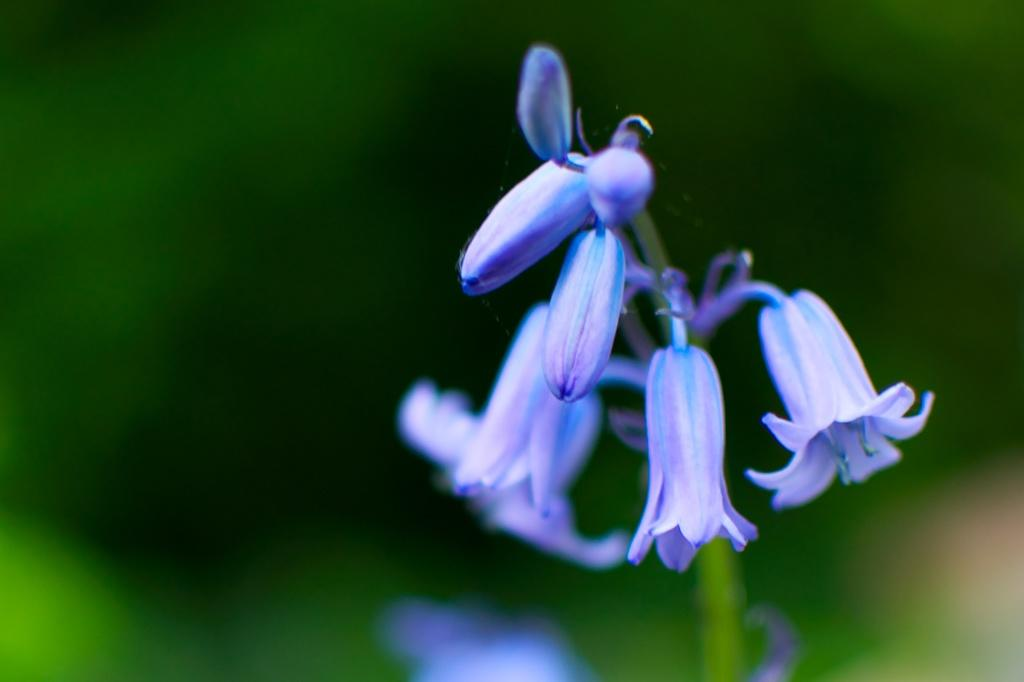What type of plant is visible in the image? There is a plant in the image. What can be seen on the plant in the image? There are flowers on the plant in the image. Are there any unopened flowers on the plant? Yes, there are buds on the plant in the image. What type of furniture is visible in the image? There is no furniture present in the image; it features a plant with flowers and buds. Can you see any rats interacting with the plant in the image? There are no rats present in the image. 